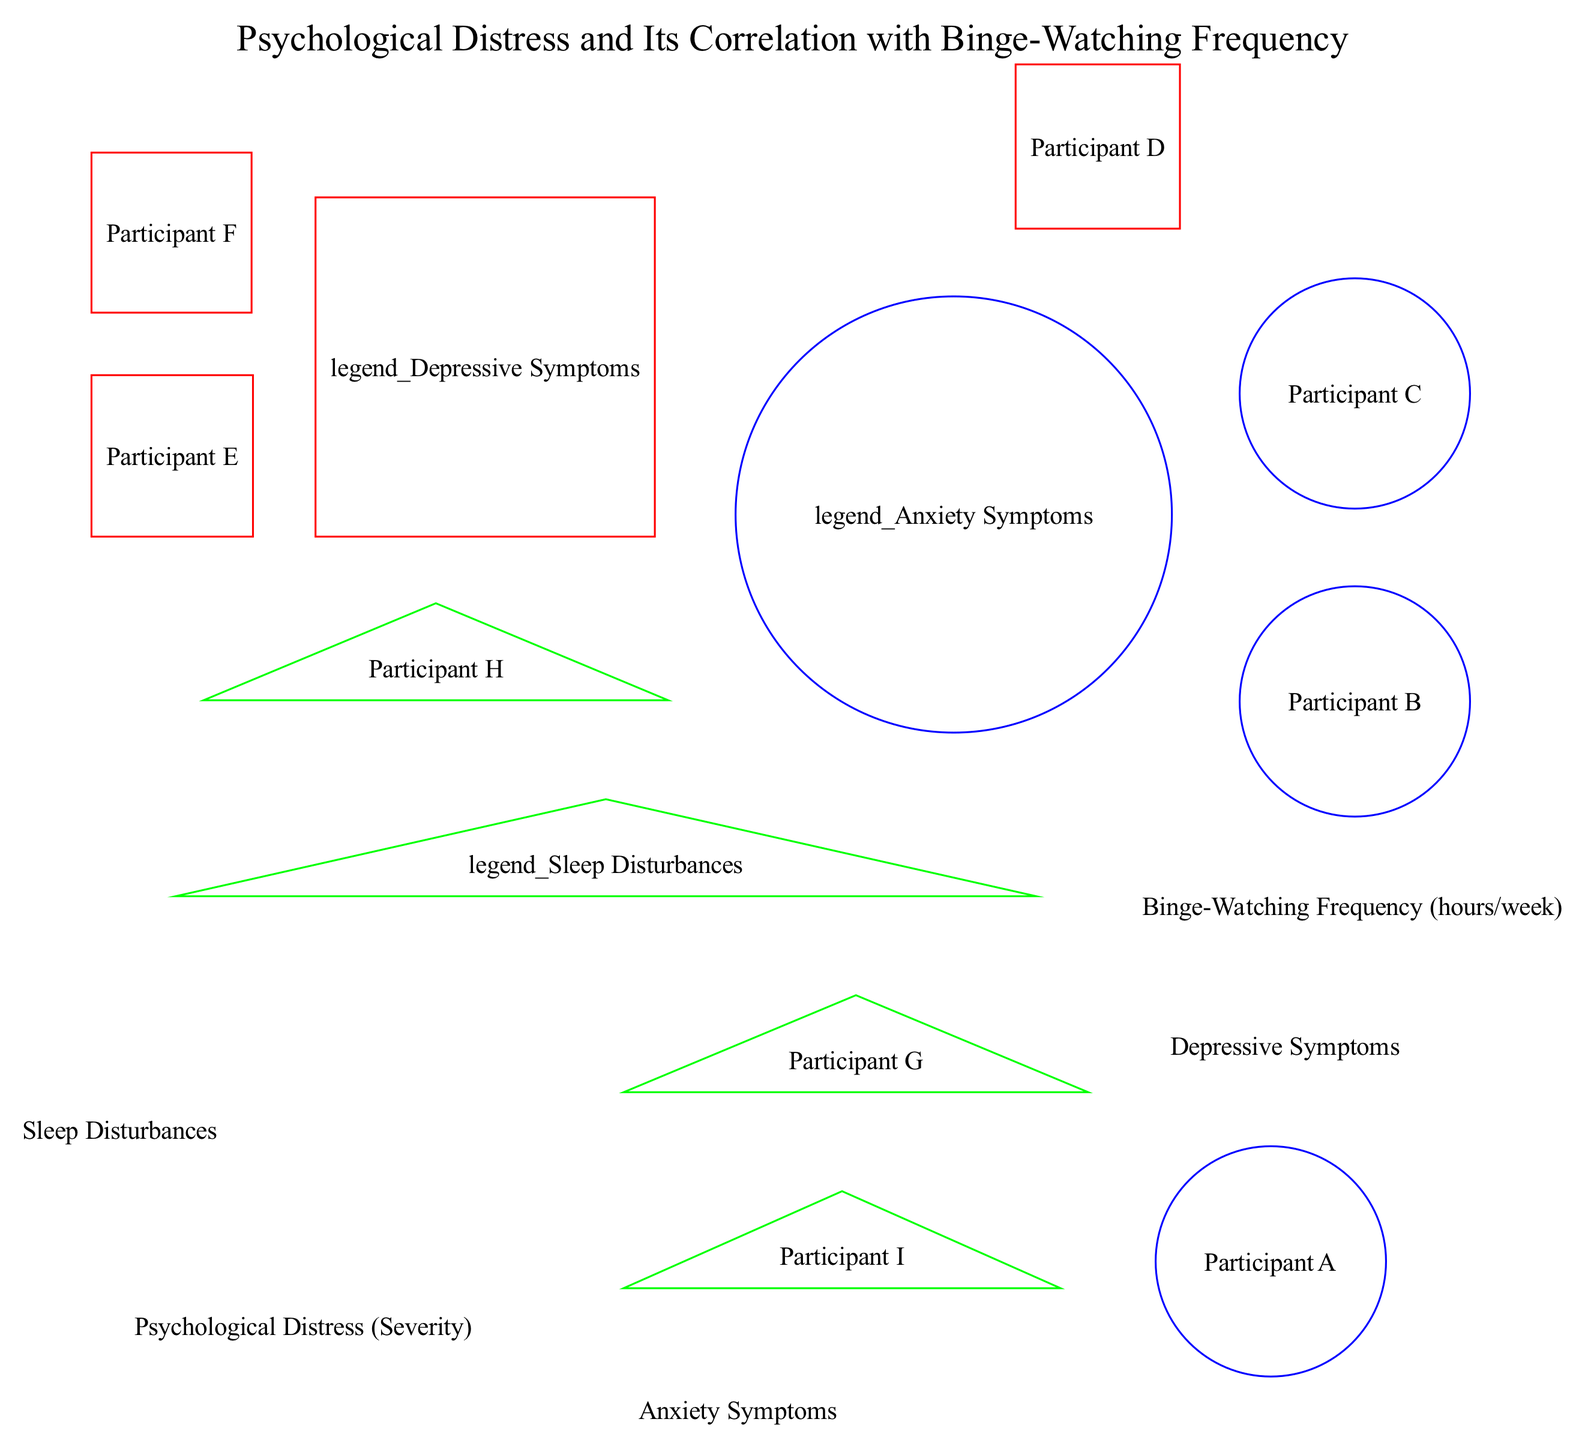What is the highest psychological distress value recorded in the diagram? The highest psychological distress value can be found by examining the y-axis values for all data points. Participant F has the highest value of 90, which corresponds to severe depression.
Answer: 90 How many participants reported mild anxiety symptoms? To find the number of participants with mild anxiety symptoms, we review the points labeled with "Anxiety Symptoms." Only Participant A is associated with mild anxiety, so there is one participant.
Answer: 1 Which participant has the highest binge-watching frequency? The binge-watching frequency is represented on the x-axis; reviewing all data points, Participant F has the highest binge-watching frequency of 30 hours per week.
Answer: Participant F What is the color representing depressive symptoms in the diagram? The legend clearly denotes the color red for "Depressive Symptoms." This information can be found by looking at the items in the legend section of the diagram.
Answer: Red How many categories of psychological symptoms are represented in the scatter plot? By reviewing the categories provided in the data, we see there are three distinct categories: Anxiety Symptoms, Depressive Symptoms, and Sleep Disturbances. Therefore, the count is three.
Answer: 3 Which participant has moderate sleep disturbance? By analyzing the data points for sleep disturbance, Participant H is explicitly labeled with "Moderate Sleep Disturbance," making them the answer.
Answer: Participant H What is the x-value for severe anxiety? The x-value for severe anxiety can be found by checking the data point associated with Participant C, whose label is "Severe Anxiety," which has an x-value of 25 hours per week.
Answer: 25 What shape represents anxiety symptoms in the diagram? According to the categories defined in the diagram, anxiety symptoms are represented with circles, which is stated in the category details.
Answer: Circle How many participants reported severe depression symptoms? By assessing the depressive symptoms category in the data points, only Participant F is labeled with "Severe Depression," indicating there is one participant.
Answer: 1 